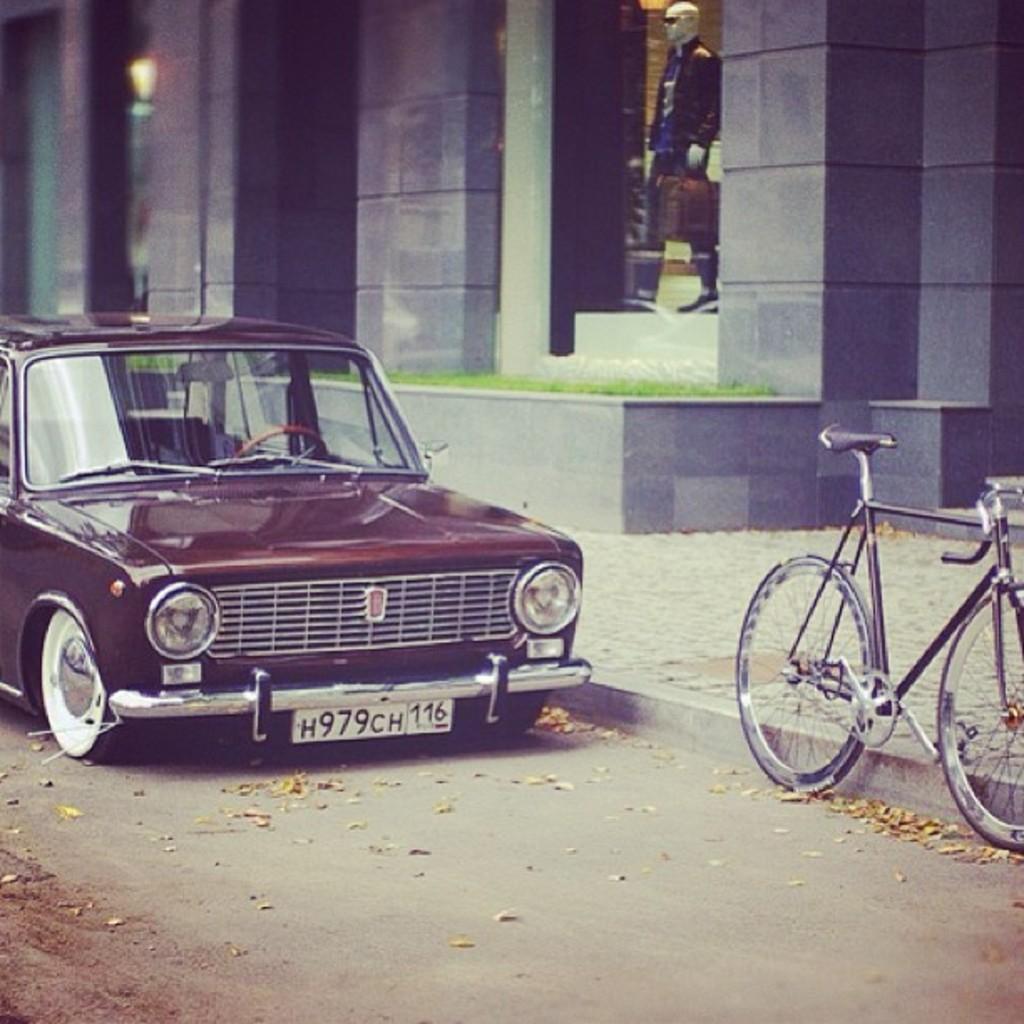Describe this image in one or two sentences. On the left side there is a car in dark red color. On the right side there is a cycle on the road. There is a building in this, there is a doll of a man in the showcase. 